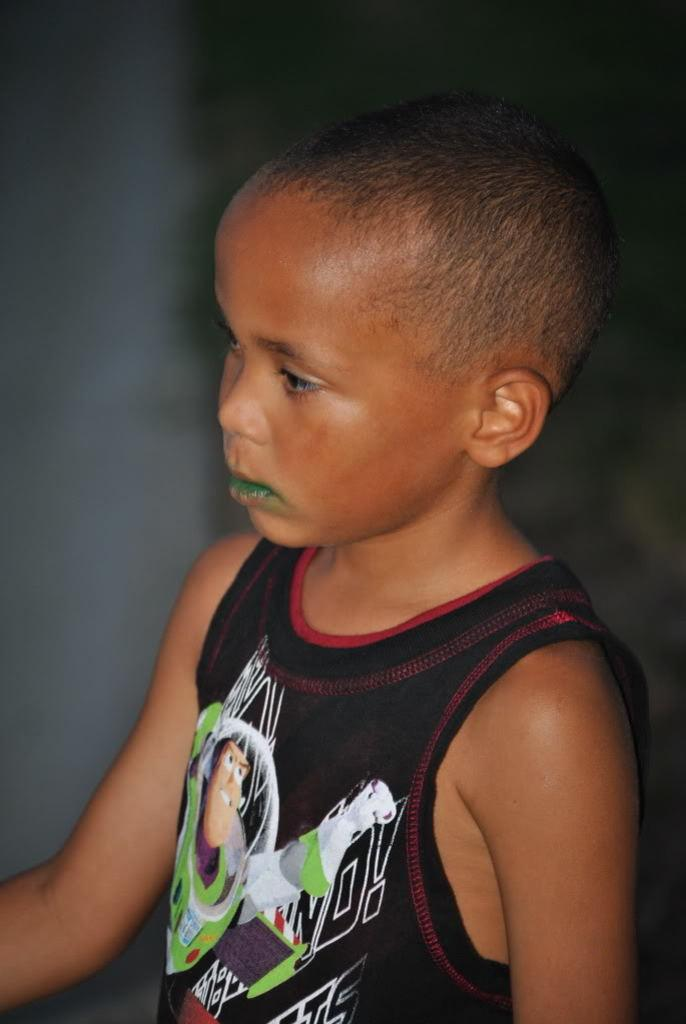What is the main subject of the image? There is a boy standing in the image. Can you describe the background of the image? The background of the image is blurry. What is causing the boy's throat to burn in the image? There is no indication in the image that the boy's throat is burning or that there is any cause for it. 